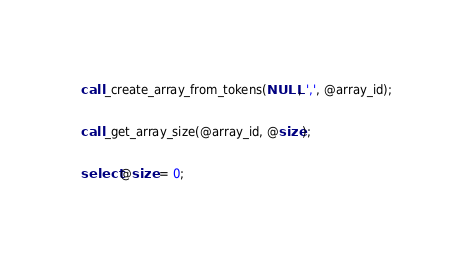<code> <loc_0><loc_0><loc_500><loc_500><_SQL_>call _create_array_from_tokens(NULL, ',', @array_id);

call _get_array_size(@array_id, @size);

select @size = 0;

</code> 